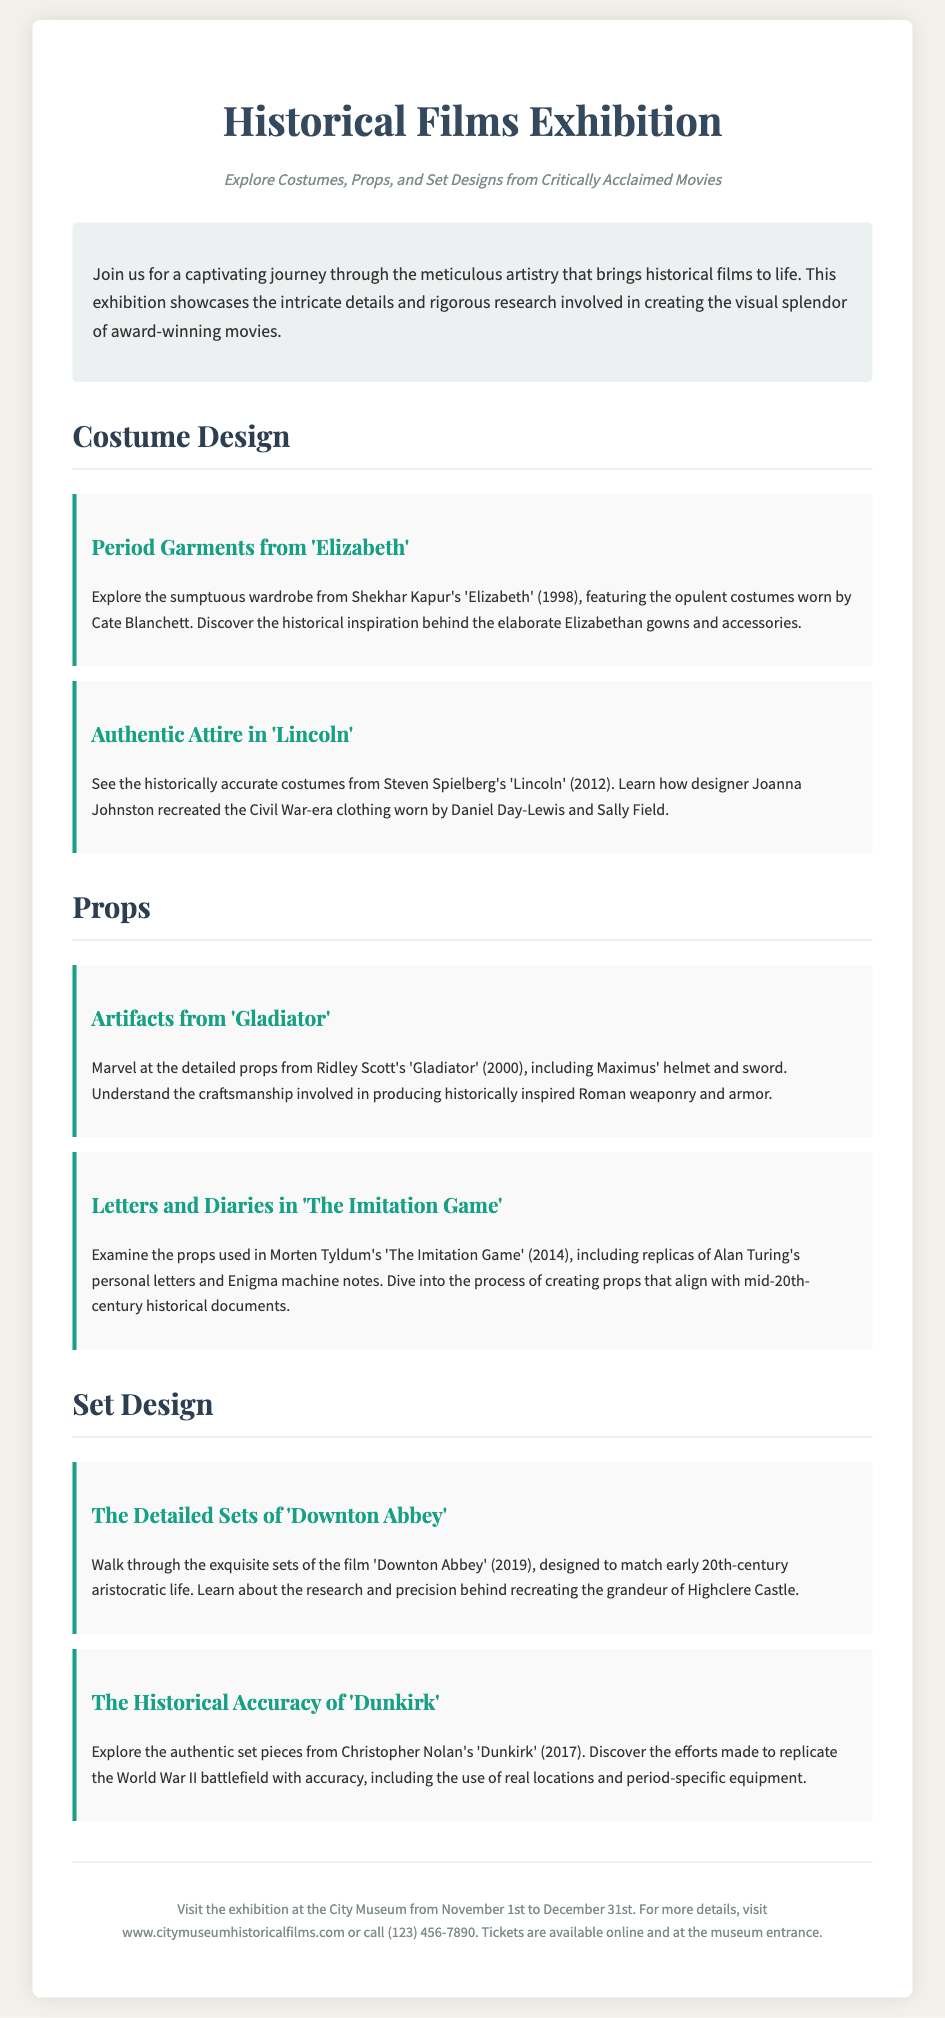what is the title of the exhibition? The title of the exhibition is prominently stated at the top of the document.
Answer: Historical Films Exhibition who directed 'Lincoln'? The document provides the director's name in the context of the film's costume design.
Answer: Steven Spielberg what is the exhibition's location? The location is mentioned in the footer section of the document.
Answer: City Museum what are the dates of the exhibition? The specific dates are detailed in the footer of the document.
Answer: November 1st to December 31st which film features costumes worn by Cate Blanchett? The document lists this film under the costume design section.
Answer: Elizabeth what type of artifacts are displayed from 'Gladiator'? The type of artifacts is described within the props section.
Answer: Helmet and sword how many films are mentioned under set design? This is determined by counting the distinct films listed in the set design section.
Answer: 2 what is the primary theme of the exhibition? The document summarizes the theme in the introduction paragraph.
Answer: Historical accuracy in films what is the phone number for more details about the exhibition? This information is located in the footer section of the document.
Answer: (123) 456-7890 